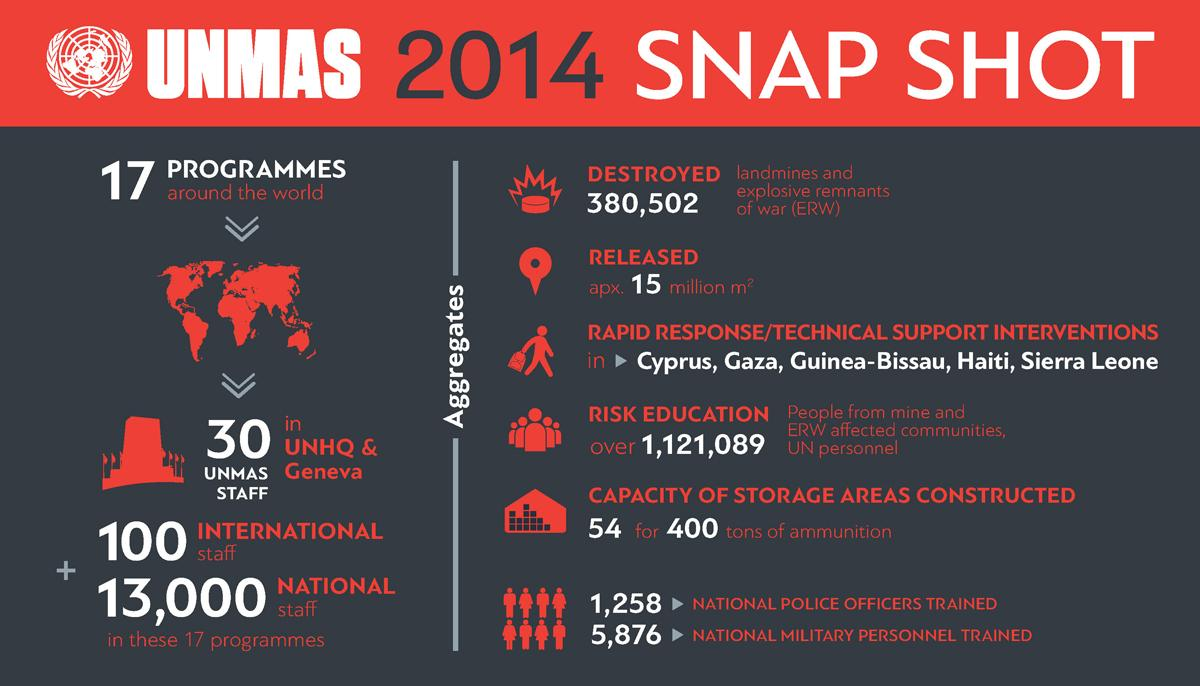Give some essential details in this illustration. In 2014, a total of 1,258 national police officers were trained by UNMAS. The storage areas constructed by UNMAS in 2014 have a capacity of 54 and can hold 400 tons of ammunition. In 2014, a total of 5,876 military personnel were trained by the United Nations Mine Action Service (UNMAS). In 2014, the United Nations Mine Action Service (UNMAS) destroyed a total of 380,502 landmines and explosive remnants of war. 